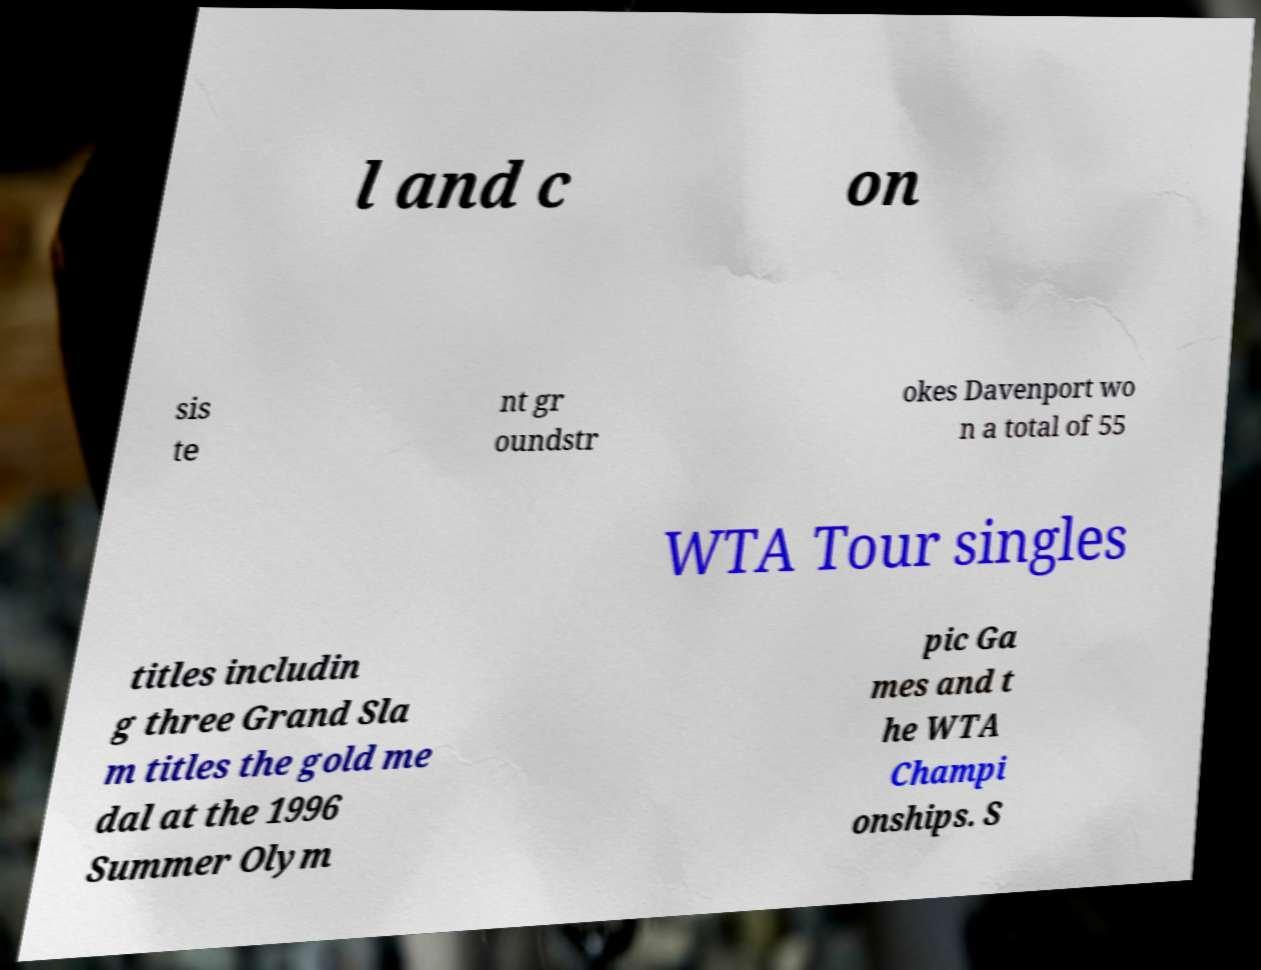Can you read and provide the text displayed in the image?This photo seems to have some interesting text. Can you extract and type it out for me? l and c on sis te nt gr oundstr okes Davenport wo n a total of 55 WTA Tour singles titles includin g three Grand Sla m titles the gold me dal at the 1996 Summer Olym pic Ga mes and t he WTA Champi onships. S 